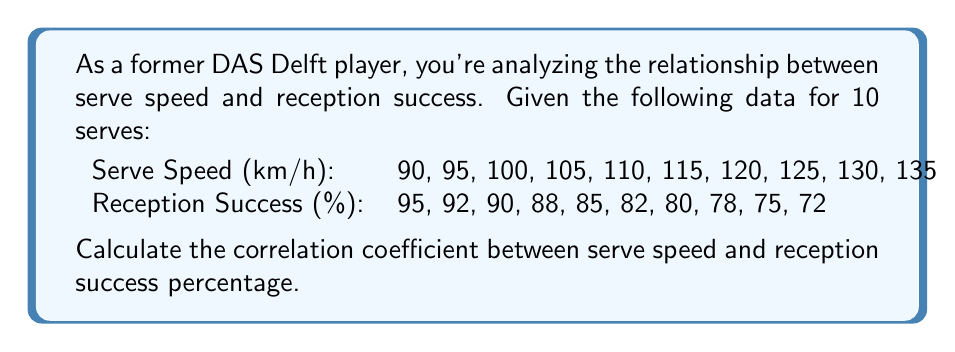What is the answer to this math problem? To calculate the correlation coefficient, we'll use the formula:

$$ r = \frac{\sum_{i=1}^{n} (x_i - \bar{x})(y_i - \bar{y})}{\sqrt{\sum_{i=1}^{n} (x_i - \bar{x})^2 \sum_{i=1}^{n} (y_i - \bar{y})^2}} $$

Where $x_i$ are serve speeds and $y_i$ are reception success percentages.

Step 1: Calculate means
$\bar{x} = \frac{90 + 95 + ... + 135}{10} = 112.5$ km/h
$\bar{y} = \frac{95 + 92 + ... + 72}{10} = 83.7\%$

Step 2: Calculate $(x_i - \bar{x})$ and $(y_i - \bar{y})$ for each pair

Step 3: Calculate $(x_i - \bar{x})(y_i - \bar{y})$, $(x_i - \bar{x})^2$, and $(y_i - \bar{y})^2$

Step 4: Sum up the results from Step 3
$\sum (x_i - \bar{x})(y_i - \bar{y}) = -1012.5$
$\sum (x_i - \bar{x})^2 = 2062.5$
$\sum (y_i - \bar{y})^2 = 506.1$

Step 5: Apply the correlation coefficient formula
$$ r = \frac{-1012.5}{\sqrt{2062.5 \times 506.1}} \approx -0.9945 $$
Answer: $r \approx -0.9945$ 